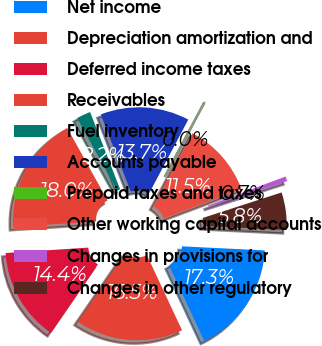Convert chart to OTSL. <chart><loc_0><loc_0><loc_500><loc_500><pie_chart><fcel>Net income<fcel>Depreciation amortization and<fcel>Deferred income taxes<fcel>Receivables<fcel>Fuel inventory<fcel>Accounts payable<fcel>Prepaid taxes and taxes<fcel>Other working capital accounts<fcel>Changes in provisions for<fcel>Changes in other regulatory<nl><fcel>17.26%<fcel>16.54%<fcel>14.38%<fcel>17.98%<fcel>2.17%<fcel>13.67%<fcel>0.01%<fcel>11.51%<fcel>0.73%<fcel>5.76%<nl></chart> 